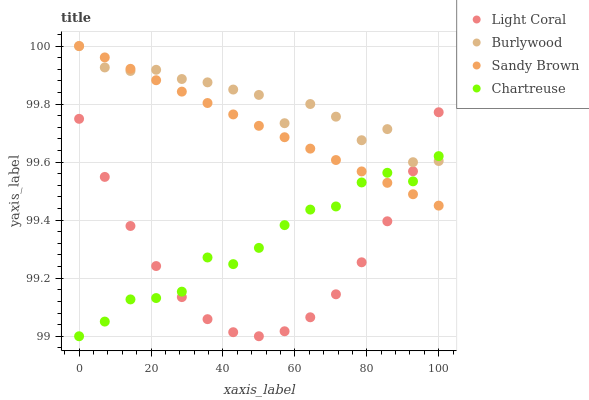Does Light Coral have the minimum area under the curve?
Answer yes or no. Yes. Does Burlywood have the maximum area under the curve?
Answer yes or no. Yes. Does Chartreuse have the minimum area under the curve?
Answer yes or no. No. Does Chartreuse have the maximum area under the curve?
Answer yes or no. No. Is Sandy Brown the smoothest?
Answer yes or no. Yes. Is Burlywood the roughest?
Answer yes or no. Yes. Is Chartreuse the smoothest?
Answer yes or no. No. Is Chartreuse the roughest?
Answer yes or no. No. Does Chartreuse have the lowest value?
Answer yes or no. Yes. Does Burlywood have the lowest value?
Answer yes or no. No. Does Sandy Brown have the highest value?
Answer yes or no. Yes. Does Burlywood have the highest value?
Answer yes or no. No. Does Chartreuse intersect Burlywood?
Answer yes or no. Yes. Is Chartreuse less than Burlywood?
Answer yes or no. No. Is Chartreuse greater than Burlywood?
Answer yes or no. No. 